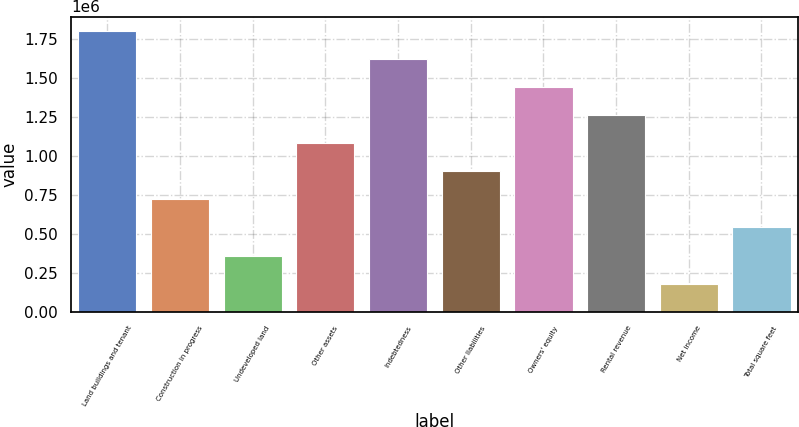<chart> <loc_0><loc_0><loc_500><loc_500><bar_chart><fcel>Land buildings and tenant<fcel>Construction in progress<fcel>Undeveloped land<fcel>Other assets<fcel>Indebtedness<fcel>Other liabilities<fcel>Owners' equity<fcel>Rental revenue<fcel>Net income<fcel>Total square feet<nl><fcel>1.803e+06<fcel>721254<fcel>360673<fcel>1.08184e+06<fcel>1.62271e+06<fcel>901545<fcel>1.44242e+06<fcel>1.26213e+06<fcel>180382<fcel>540964<nl></chart> 